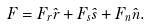<formula> <loc_0><loc_0><loc_500><loc_500>F = F _ { r } \hat { r } + F _ { s } \hat { s } + F _ { n } \hat { n } .</formula> 